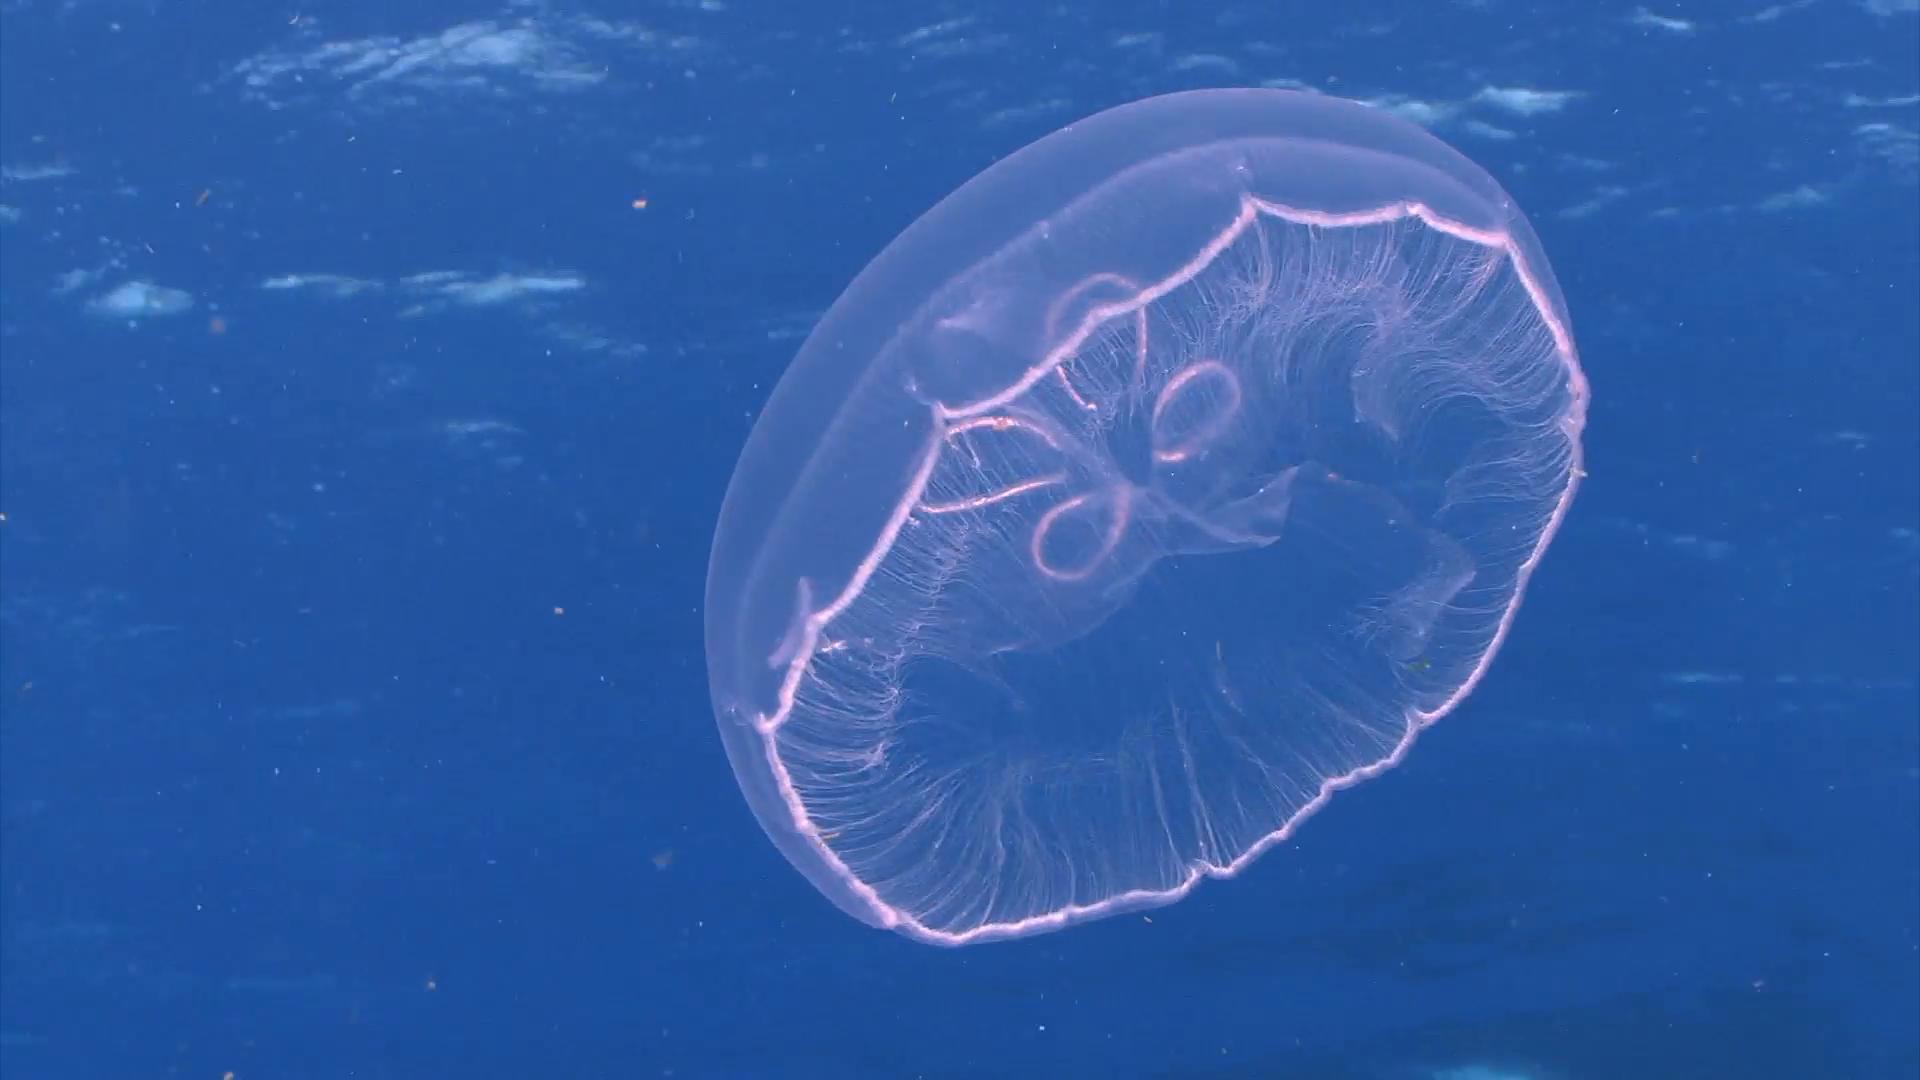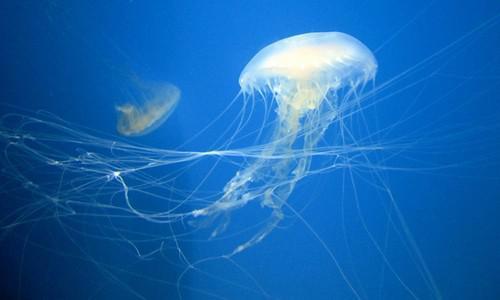The first image is the image on the left, the second image is the image on the right. Considering the images on both sides, is "In at least one image there is a circle jellyfish with its head looking like a four leaf clover." valid? Answer yes or no. Yes. 